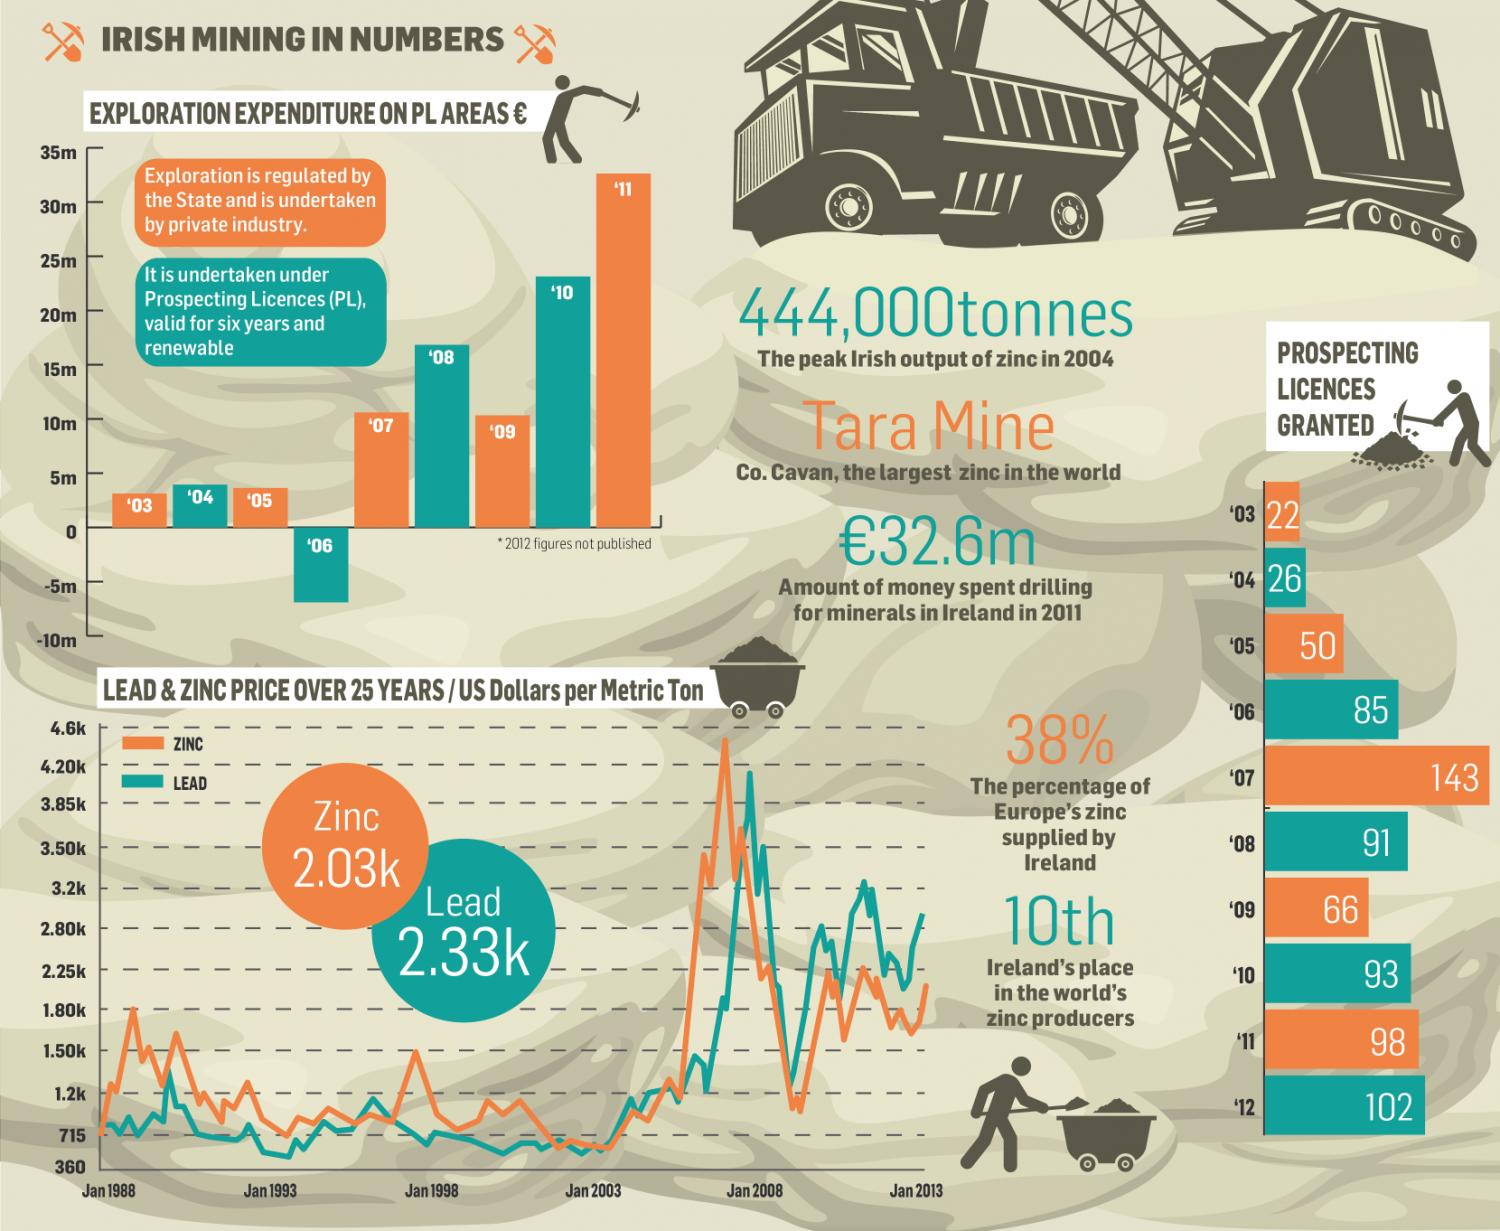Outline some significant characteristics in this image. A total of 62% of the zinc supplied to Europe does not come from Ireland. Zinc-blue, orange, and green are represented by the color orange. 